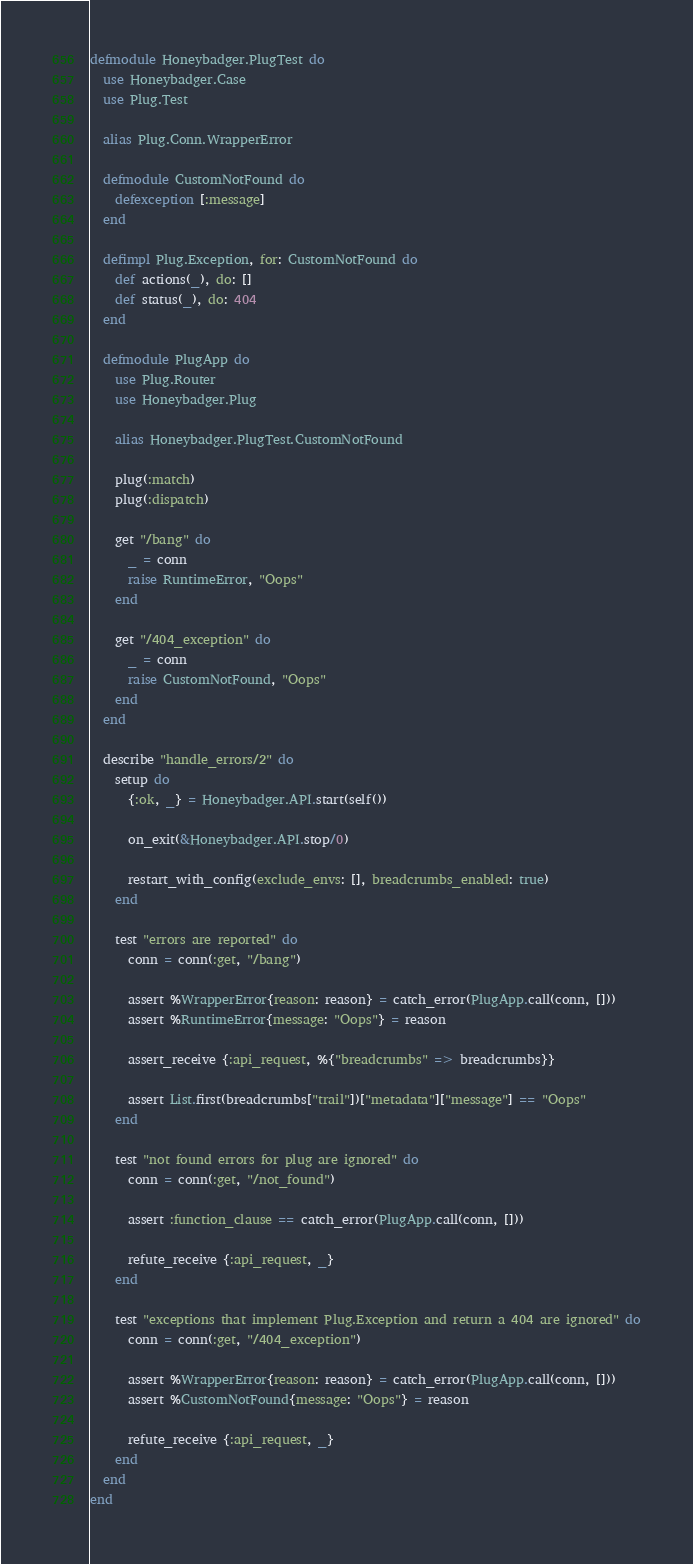<code> <loc_0><loc_0><loc_500><loc_500><_Elixir_>defmodule Honeybadger.PlugTest do
  use Honeybadger.Case
  use Plug.Test

  alias Plug.Conn.WrapperError

  defmodule CustomNotFound do
    defexception [:message]
  end

  defimpl Plug.Exception, for: CustomNotFound do
    def actions(_), do: []
    def status(_), do: 404
  end

  defmodule PlugApp do
    use Plug.Router
    use Honeybadger.Plug

    alias Honeybadger.PlugTest.CustomNotFound

    plug(:match)
    plug(:dispatch)

    get "/bang" do
      _ = conn
      raise RuntimeError, "Oops"
    end

    get "/404_exception" do
      _ = conn
      raise CustomNotFound, "Oops"
    end
  end

  describe "handle_errors/2" do
    setup do
      {:ok, _} = Honeybadger.API.start(self())

      on_exit(&Honeybadger.API.stop/0)

      restart_with_config(exclude_envs: [], breadcrumbs_enabled: true)
    end

    test "errors are reported" do
      conn = conn(:get, "/bang")

      assert %WrapperError{reason: reason} = catch_error(PlugApp.call(conn, []))
      assert %RuntimeError{message: "Oops"} = reason

      assert_receive {:api_request, %{"breadcrumbs" => breadcrumbs}}

      assert List.first(breadcrumbs["trail"])["metadata"]["message"] == "Oops"
    end

    test "not found errors for plug are ignored" do
      conn = conn(:get, "/not_found")

      assert :function_clause == catch_error(PlugApp.call(conn, []))

      refute_receive {:api_request, _}
    end

    test "exceptions that implement Plug.Exception and return a 404 are ignored" do
      conn = conn(:get, "/404_exception")

      assert %WrapperError{reason: reason} = catch_error(PlugApp.call(conn, []))
      assert %CustomNotFound{message: "Oops"} = reason

      refute_receive {:api_request, _}
    end
  end
end
</code> 